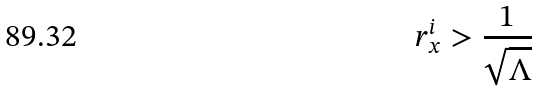Convert formula to latex. <formula><loc_0><loc_0><loc_500><loc_500>r ^ { i } _ { x } > \frac { 1 } { \sqrt { \Lambda } }</formula> 